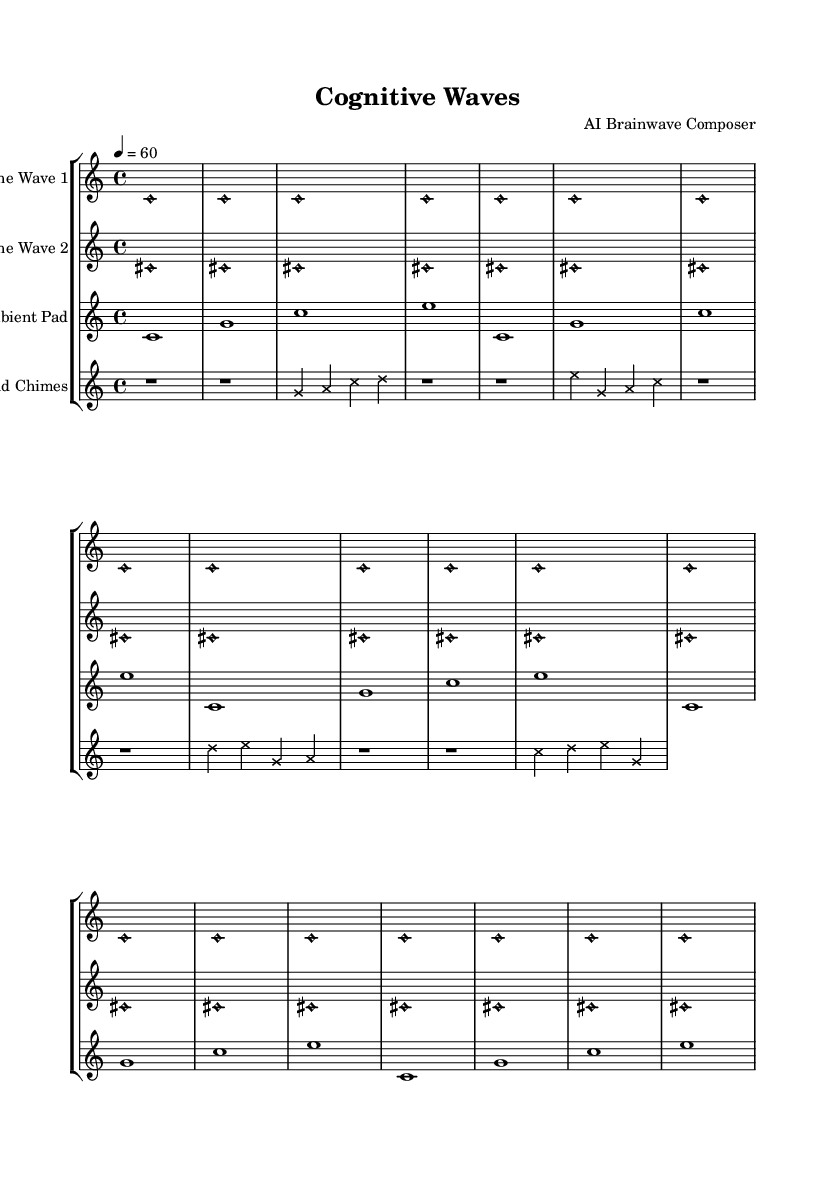What is the key signature of this music? The key signature is indicated at the beginning of the score, which shows no sharps or flats, signifying C major.
Answer: C major What is the time signature of this piece? The time signature is found at the beginning of the sheet music, represented as 4/4, which means there are four beats per measure.
Answer: 4/4 What is the tempo marking for this composition? The tempo marking is stated in the score, indicating a tempo of quarter note = 60 beats per minute.
Answer: 60 How many measures are there for the Sine Wave 1 part? The Sine Wave 1 part shows a repeated structure of 20 instances of a single note, visually translating to 20 measures in total.
Answer: 20 What instrument accompanies the wind chimes? The score shows that the wind chimes are part of a staff grouped with additional sounds, specifically alongside sine waves and an ambient pad, which contributes to the overall experience of the piece.
Answer: Ambient Pad What type of sound is used for Sine Wave 2? The score indicates the use of a non-harmonic style for the notes in Sine Wave 2 making it distinct in sound characterization, highlighting the Experimental nature of the piece.
Answer: Harmonic How many different instruments are represented in the score? The score contains distinct sections for four instruments, as indicated by four separate staves, each labeled with the instrument name.
Answer: Four 